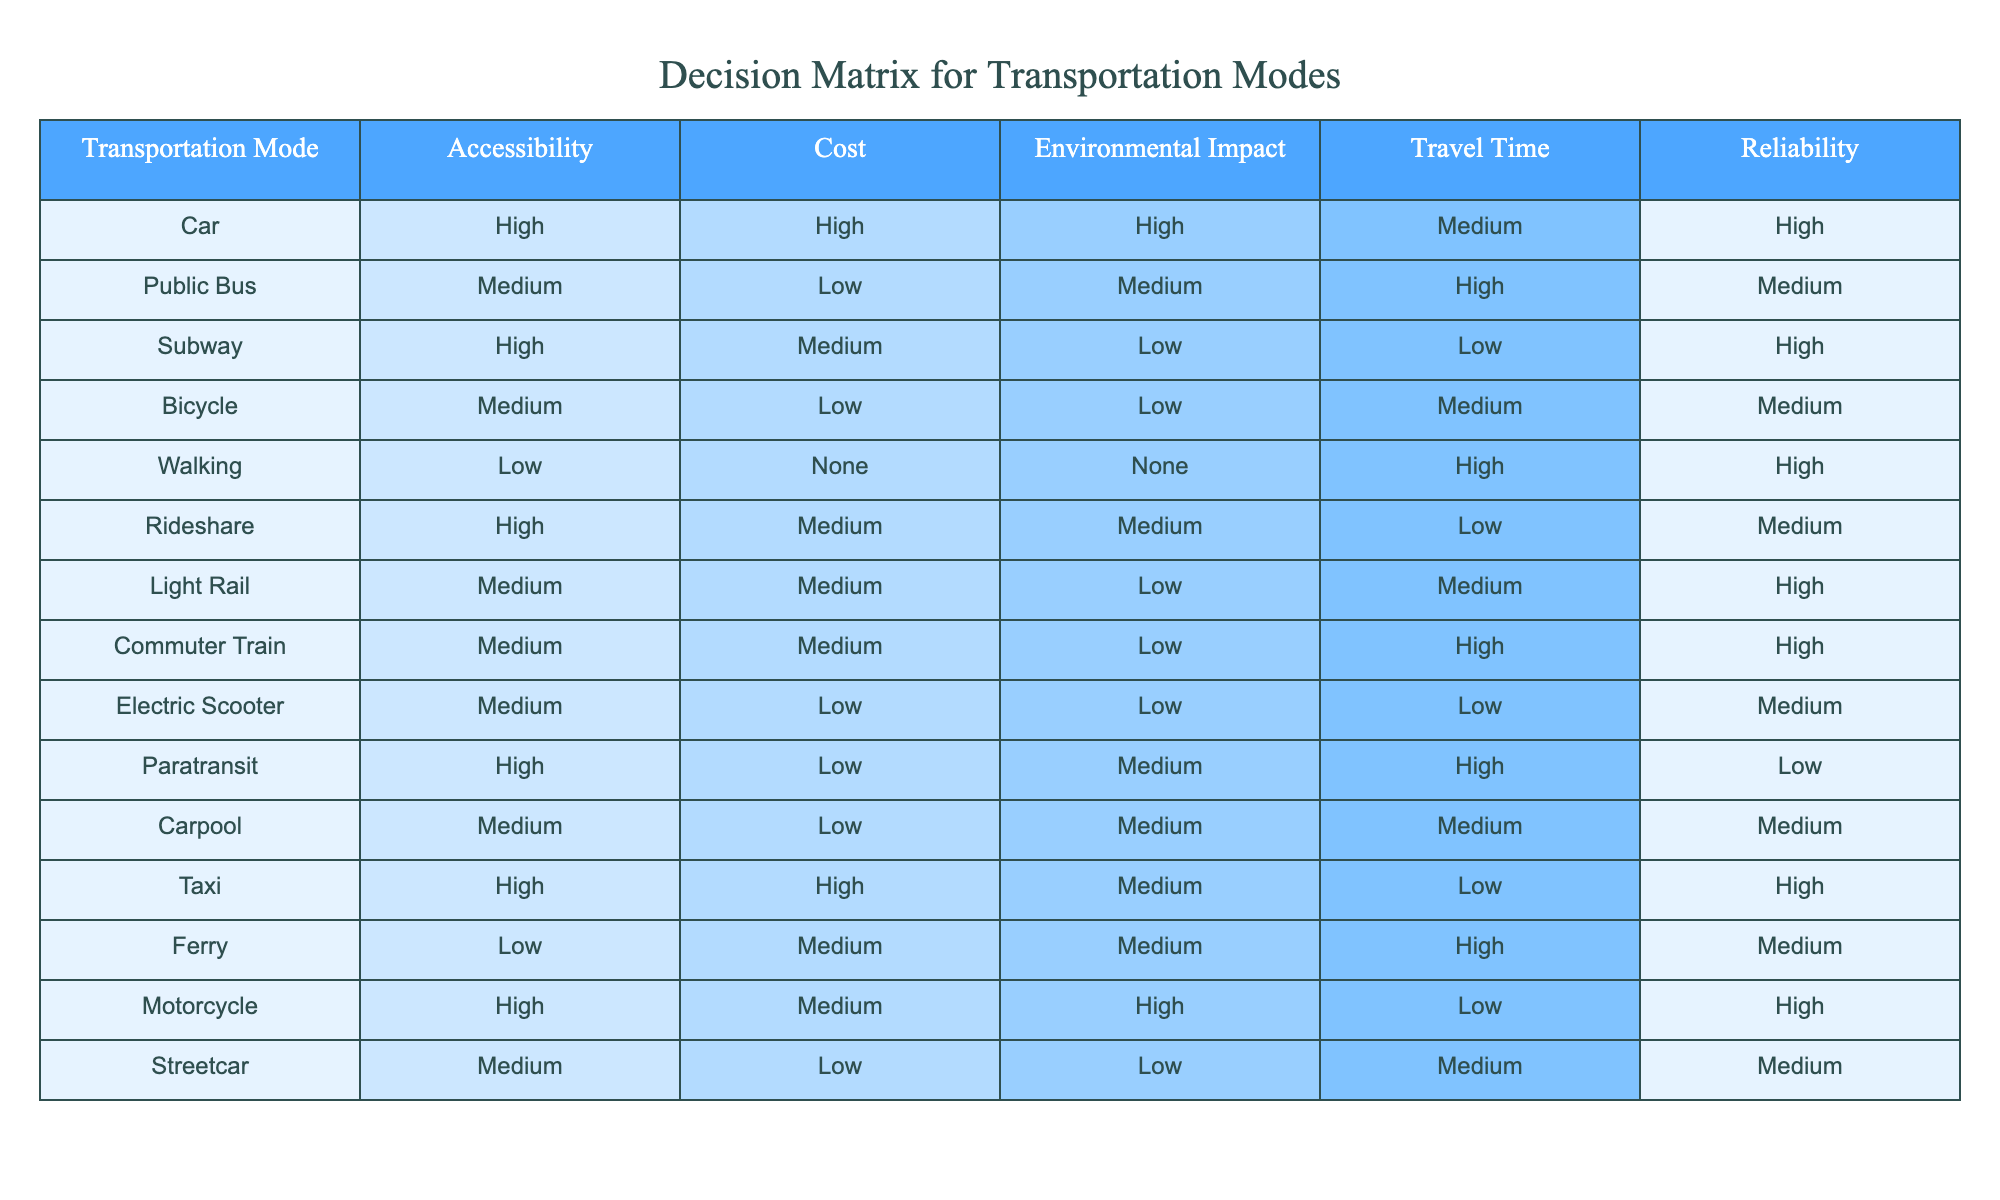What is the cost of using a bicycle for transportation? The table shows the cost for each transportation mode, and for a bicycle, the cost is listed as low.
Answer: Low Which transportation modes have high accessibility and medium cost? By looking at the table, the modes that exhibit both high accessibility and medium cost are the subway and rideshare.
Answer: Subway, Rideshare Is walking a transportation mode that has a cost associated with it? According to the table, walking is marked as having no cost, which indicates that it is free.
Answer: No What is the environmental impact of using a commuter train? The table indicates that the environmental impact of a commuter train is low, as per the provided data for this mode of transportation.
Answer: Low How does the travel time of a bicycle compare to that of a public bus? The travel time of a bicycle is medium, while for a public bus it is high. Since medium is less than high, this means that a bicycle generally offers a shorter travel time than a public bus.
Answer: Shorter What is the average cost of the transportation modes that have a low environmental impact? The transportation modes with low environmental impact are subway, bicycle, electric scooter, and streetcar. Their respective costs are medium, low, low, and low, which sum up to medium (2), low (2). To calculate the average, convert medium to 2 and low to 1 and sum all costs: (2 + 1 + 1 + 1) = 5, and divide by 4 modes (5/4 = 1.25) gives a result closer to low.
Answer: Low Which transportation mode has the highest reliability? The table shows that the car, subway, and motorcycle all have high reliability, making them the modes with the highest reliability.
Answer: Car, Subway, Motorcycle Does paratransit have a high accessibility rating? The details in the table specify that paratransit has high accessibility, confirming that it can be considered a highly accessible mode of transportation.
Answer: Yes 